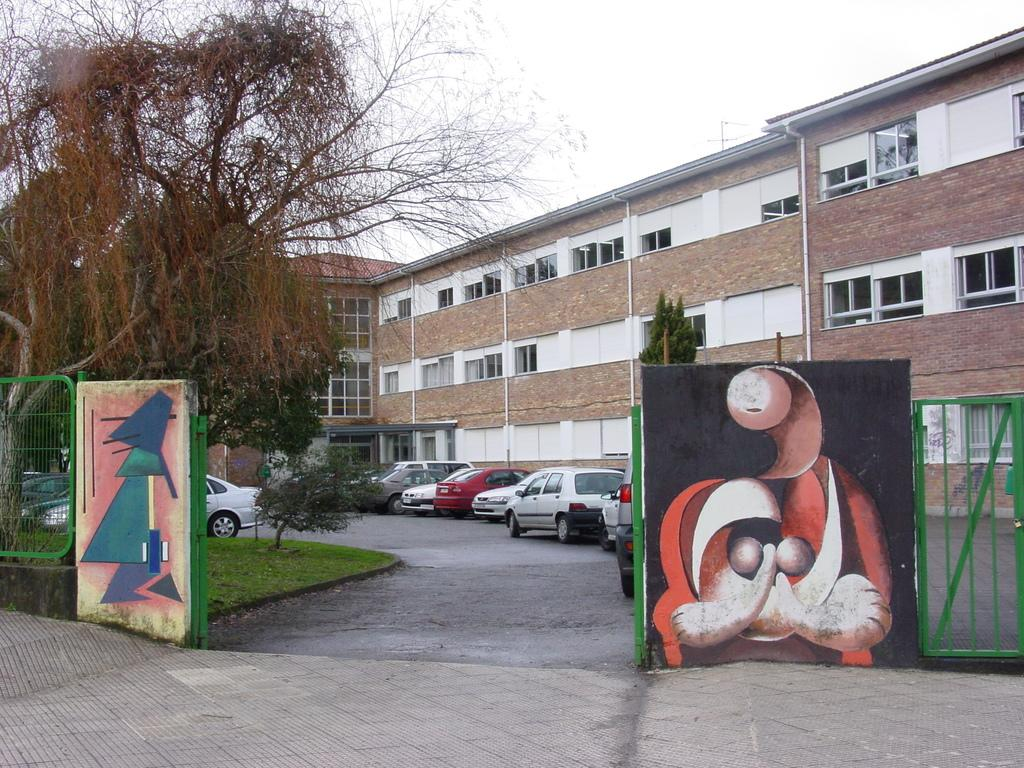What type of structures can be seen in the image? There are buildings in the image. What else is present in the image besides buildings? Motor vehicles, plants, the ground, trees, grills, and pictures near the gate are visible in the image. Can you describe the natural elements in the image? Plants and trees are visible in the image. What is the surface on which the buildings and other objects are situated? The ground is visible in the image. What is visible in the sky in the image? The sky is visible in the image. How many bananas are hanging from the trees in the image? There are no bananas visible in the image; only plants and trees are present. Can you describe the growth rate of the plants in the image? The growth rate of the plants cannot be determined from the image alone. 